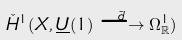<formula> <loc_0><loc_0><loc_500><loc_500>\check { H } ^ { 1 } ( X , \underline { U } ( 1 ) \overset { \tilde { d } } \longrightarrow \Omega ^ { 1 } _ { \mathbb { R } } )</formula> 